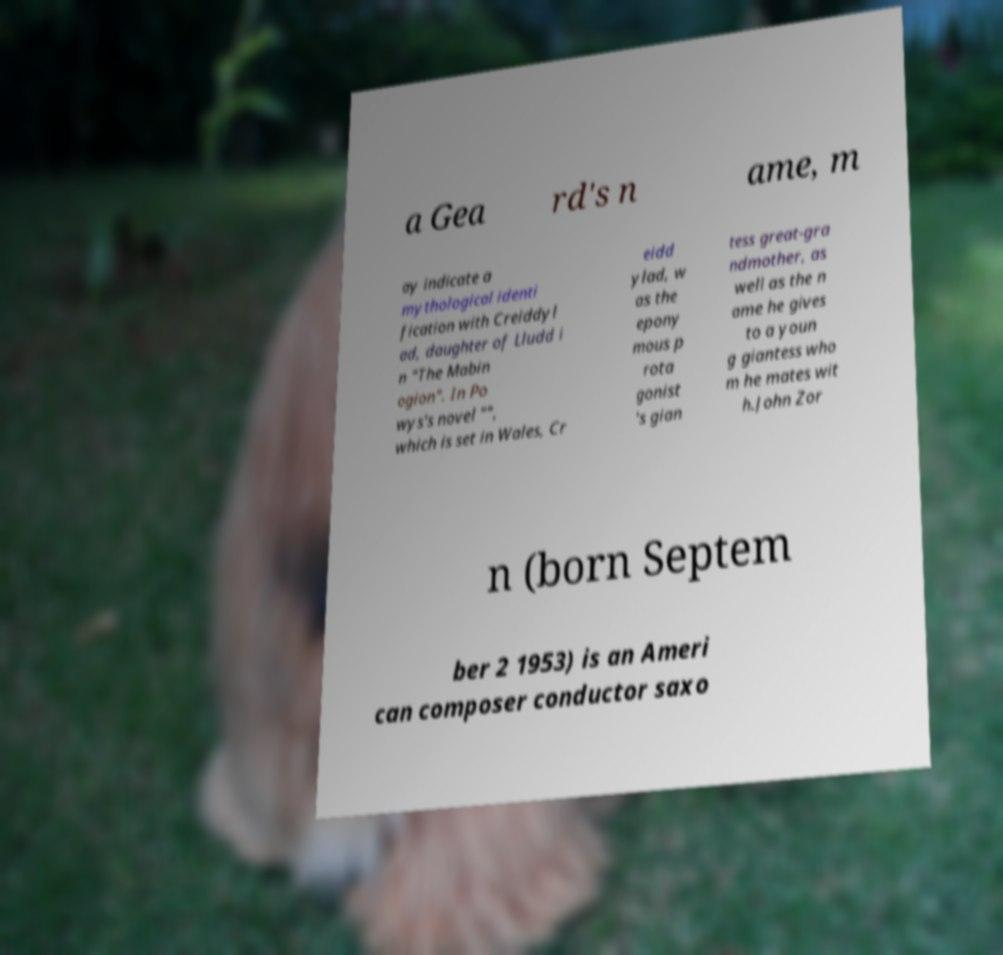I need the written content from this picture converted into text. Can you do that? a Gea rd's n ame, m ay indicate a mythological identi fication with Creiddyl ad, daughter of Lludd i n "The Mabin ogion". In Po wys's novel "", which is set in Wales, Cr eidd ylad, w as the epony mous p rota gonist 's gian tess great-gra ndmother, as well as the n ame he gives to a youn g giantess who m he mates wit h.John Zor n (born Septem ber 2 1953) is an Ameri can composer conductor saxo 